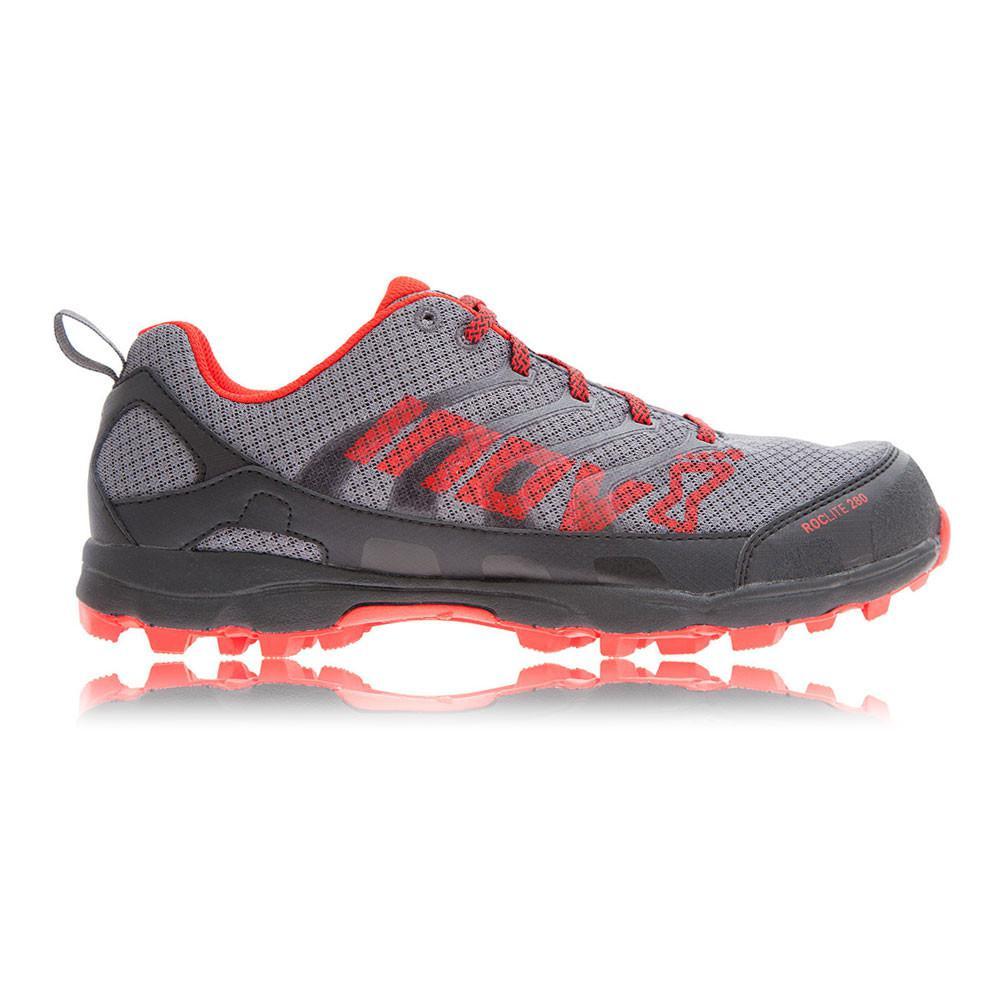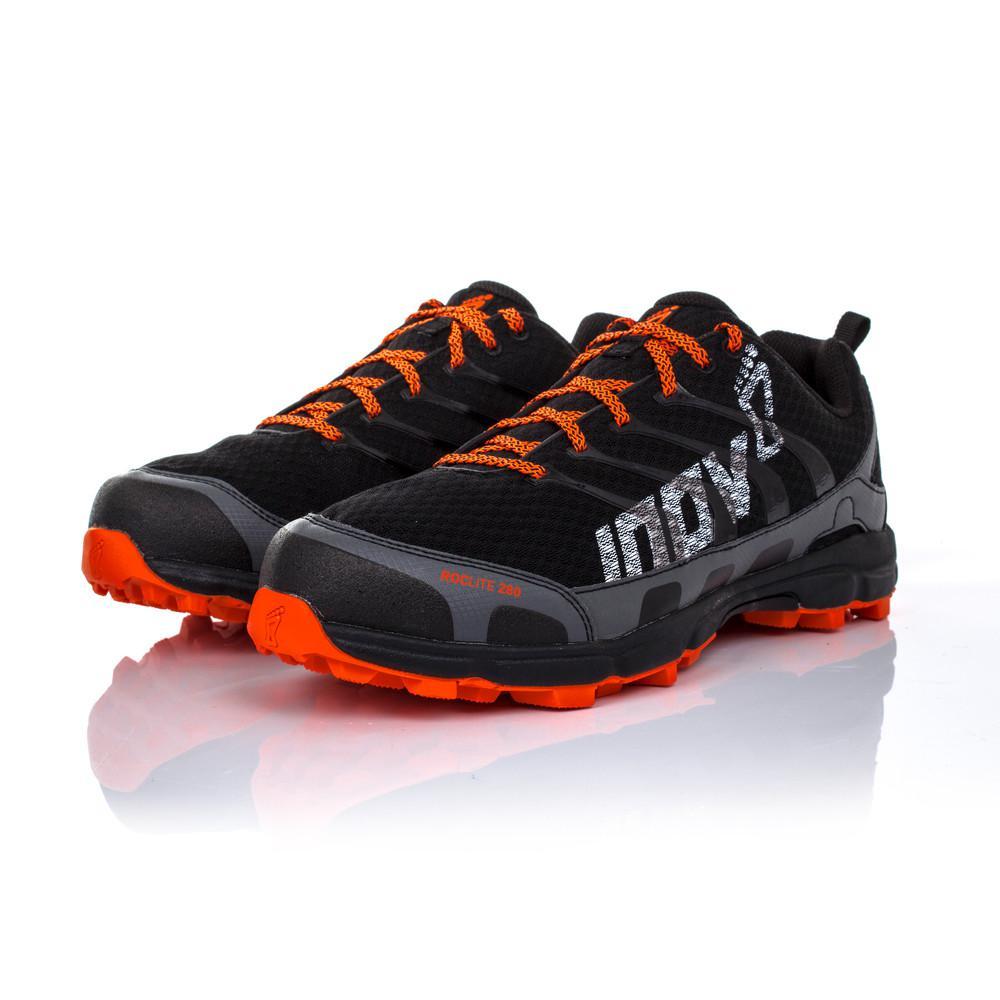The first image is the image on the left, the second image is the image on the right. Considering the images on both sides, is "The left image contains one leftward angled sneaker, and the right image contains a pair of sneakers posed side-by-side heel-to-toe." valid? Answer yes or no. No. The first image is the image on the left, the second image is the image on the right. Assess this claim about the two images: "In one image, a pair of shoes has one shoe facing forward and one facing backward, the color of the shoe soles matching the inside fabric.". Correct or not? Answer yes or no. No. 